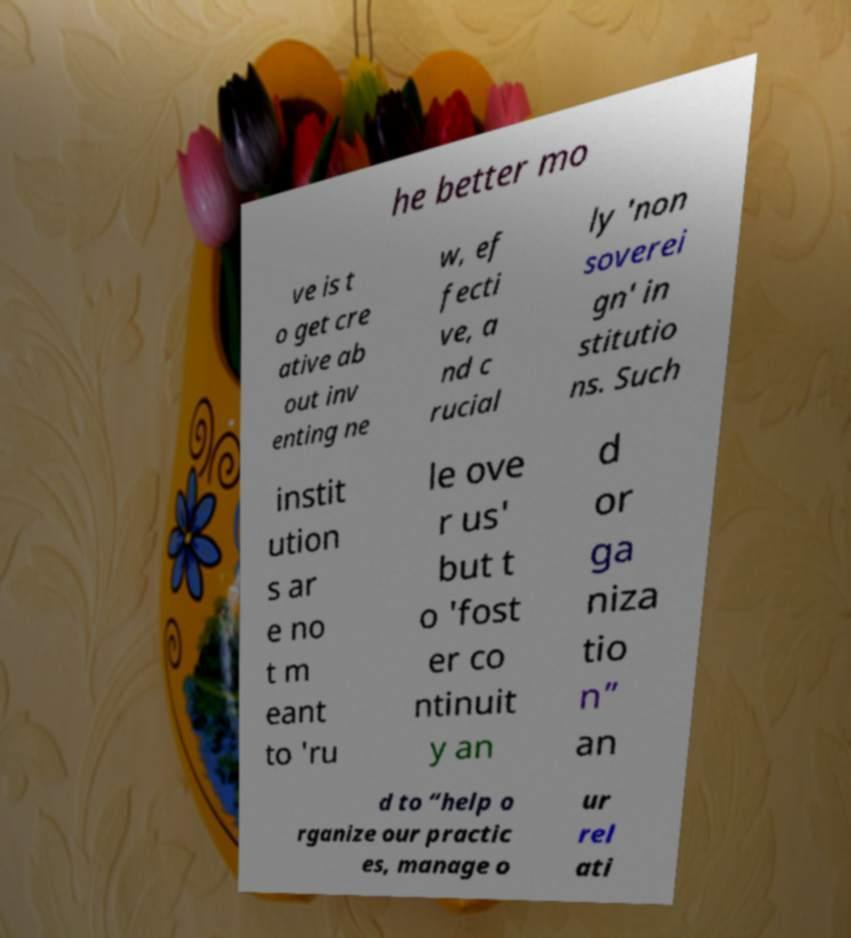What messages or text are displayed in this image? I need them in a readable, typed format. he better mo ve is t o get cre ative ab out inv enting ne w, ef fecti ve, a nd c rucial ly 'non soverei gn' in stitutio ns. Such instit ution s ar e no t m eant to 'ru le ove r us' but t o 'fost er co ntinuit y an d or ga niza tio n” an d to “help o rganize our practic es, manage o ur rel ati 